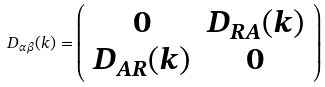<formula> <loc_0><loc_0><loc_500><loc_500>D _ { \alpha \beta } ( k ) = \left ( \begin{array} { c c } 0 & D _ { R A } ( k ) \\ D _ { A R } ( k ) & 0 \end{array} \right )</formula> 